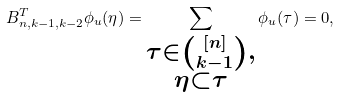<formula> <loc_0><loc_0><loc_500><loc_500>B ^ { T } _ { n , k - 1 , k - 2 } \phi _ { u } ( \eta ) = \sum _ { \substack { \tau \in \binom { [ n ] } { k - 1 } , \\ \eta \subset \tau } } \phi _ { u } ( \tau ) = 0 ,</formula> 